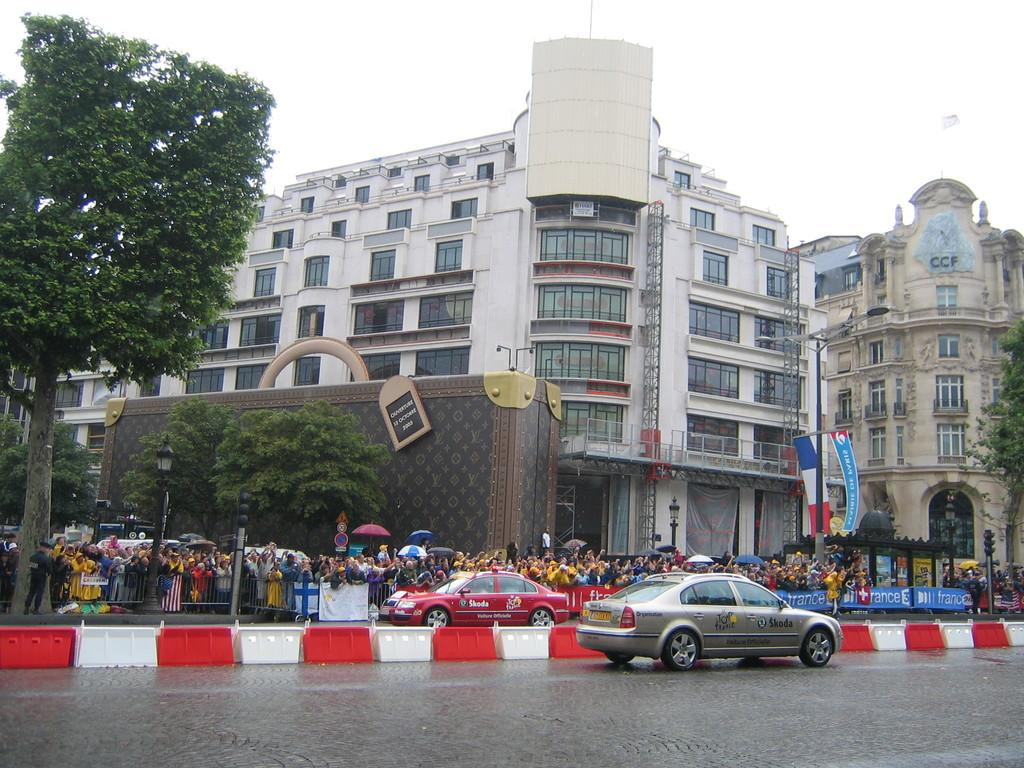Provide a one-sentence caption for the provided image. A city scene with a silver car in the foreground that says Skoda. 